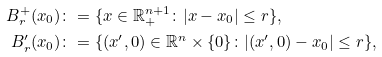Convert formula to latex. <formula><loc_0><loc_0><loc_500><loc_500>B _ { r } ^ { + } ( x _ { 0 } ) & \colon = \{ x \in \mathbb { R } _ { + } ^ { n + 1 } \colon | x - x _ { 0 } | \leq r \} , \\ B _ { r } ^ { \prime } ( x _ { 0 } ) & \colon = \{ ( x ^ { \prime } , 0 ) \in \mathbb { R } ^ { n } \times \{ 0 \} \colon | ( x ^ { \prime } , 0 ) - x _ { 0 } | \leq r \} ,</formula> 